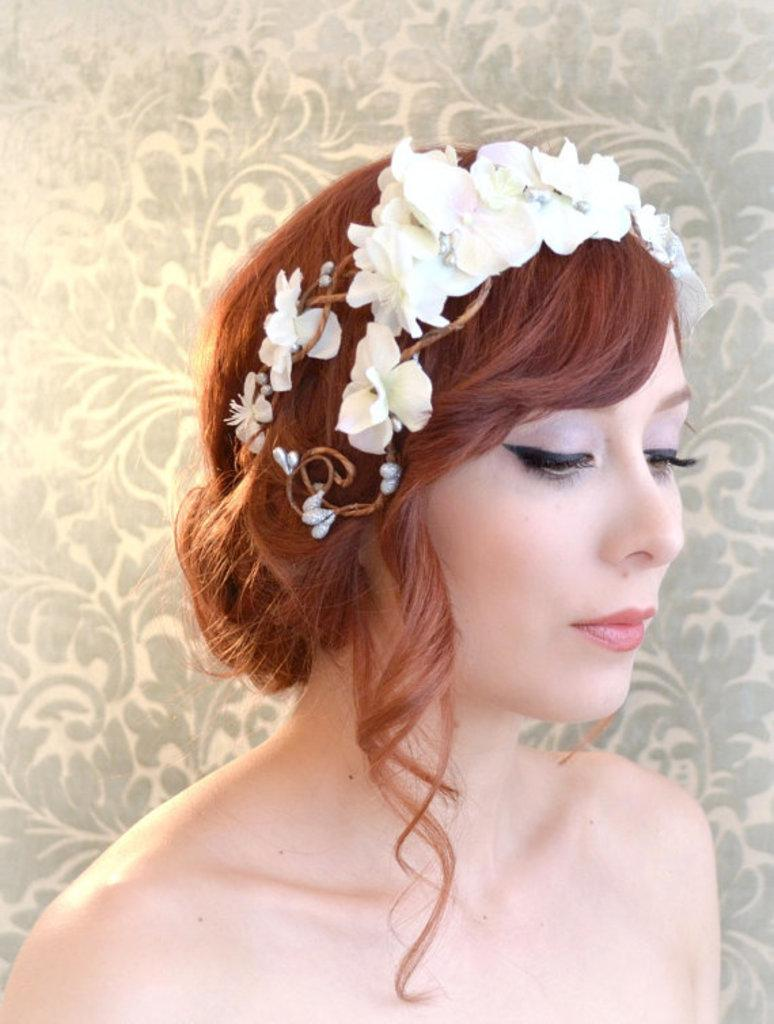Who is the main subject in the image? There is a lady in the image. What can be seen behind the lady? There is a design background behind the lady. What is the lady wearing on her head? The lady is wearing flowers on her head. What type of vest is the lady wearing in the image? There is no vest visible in the image; the lady is wearing flowers on her head. 